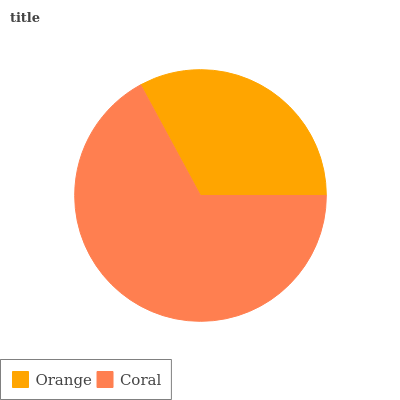Is Orange the minimum?
Answer yes or no. Yes. Is Coral the maximum?
Answer yes or no. Yes. Is Coral the minimum?
Answer yes or no. No. Is Coral greater than Orange?
Answer yes or no. Yes. Is Orange less than Coral?
Answer yes or no. Yes. Is Orange greater than Coral?
Answer yes or no. No. Is Coral less than Orange?
Answer yes or no. No. Is Coral the high median?
Answer yes or no. Yes. Is Orange the low median?
Answer yes or no. Yes. Is Orange the high median?
Answer yes or no. No. Is Coral the low median?
Answer yes or no. No. 